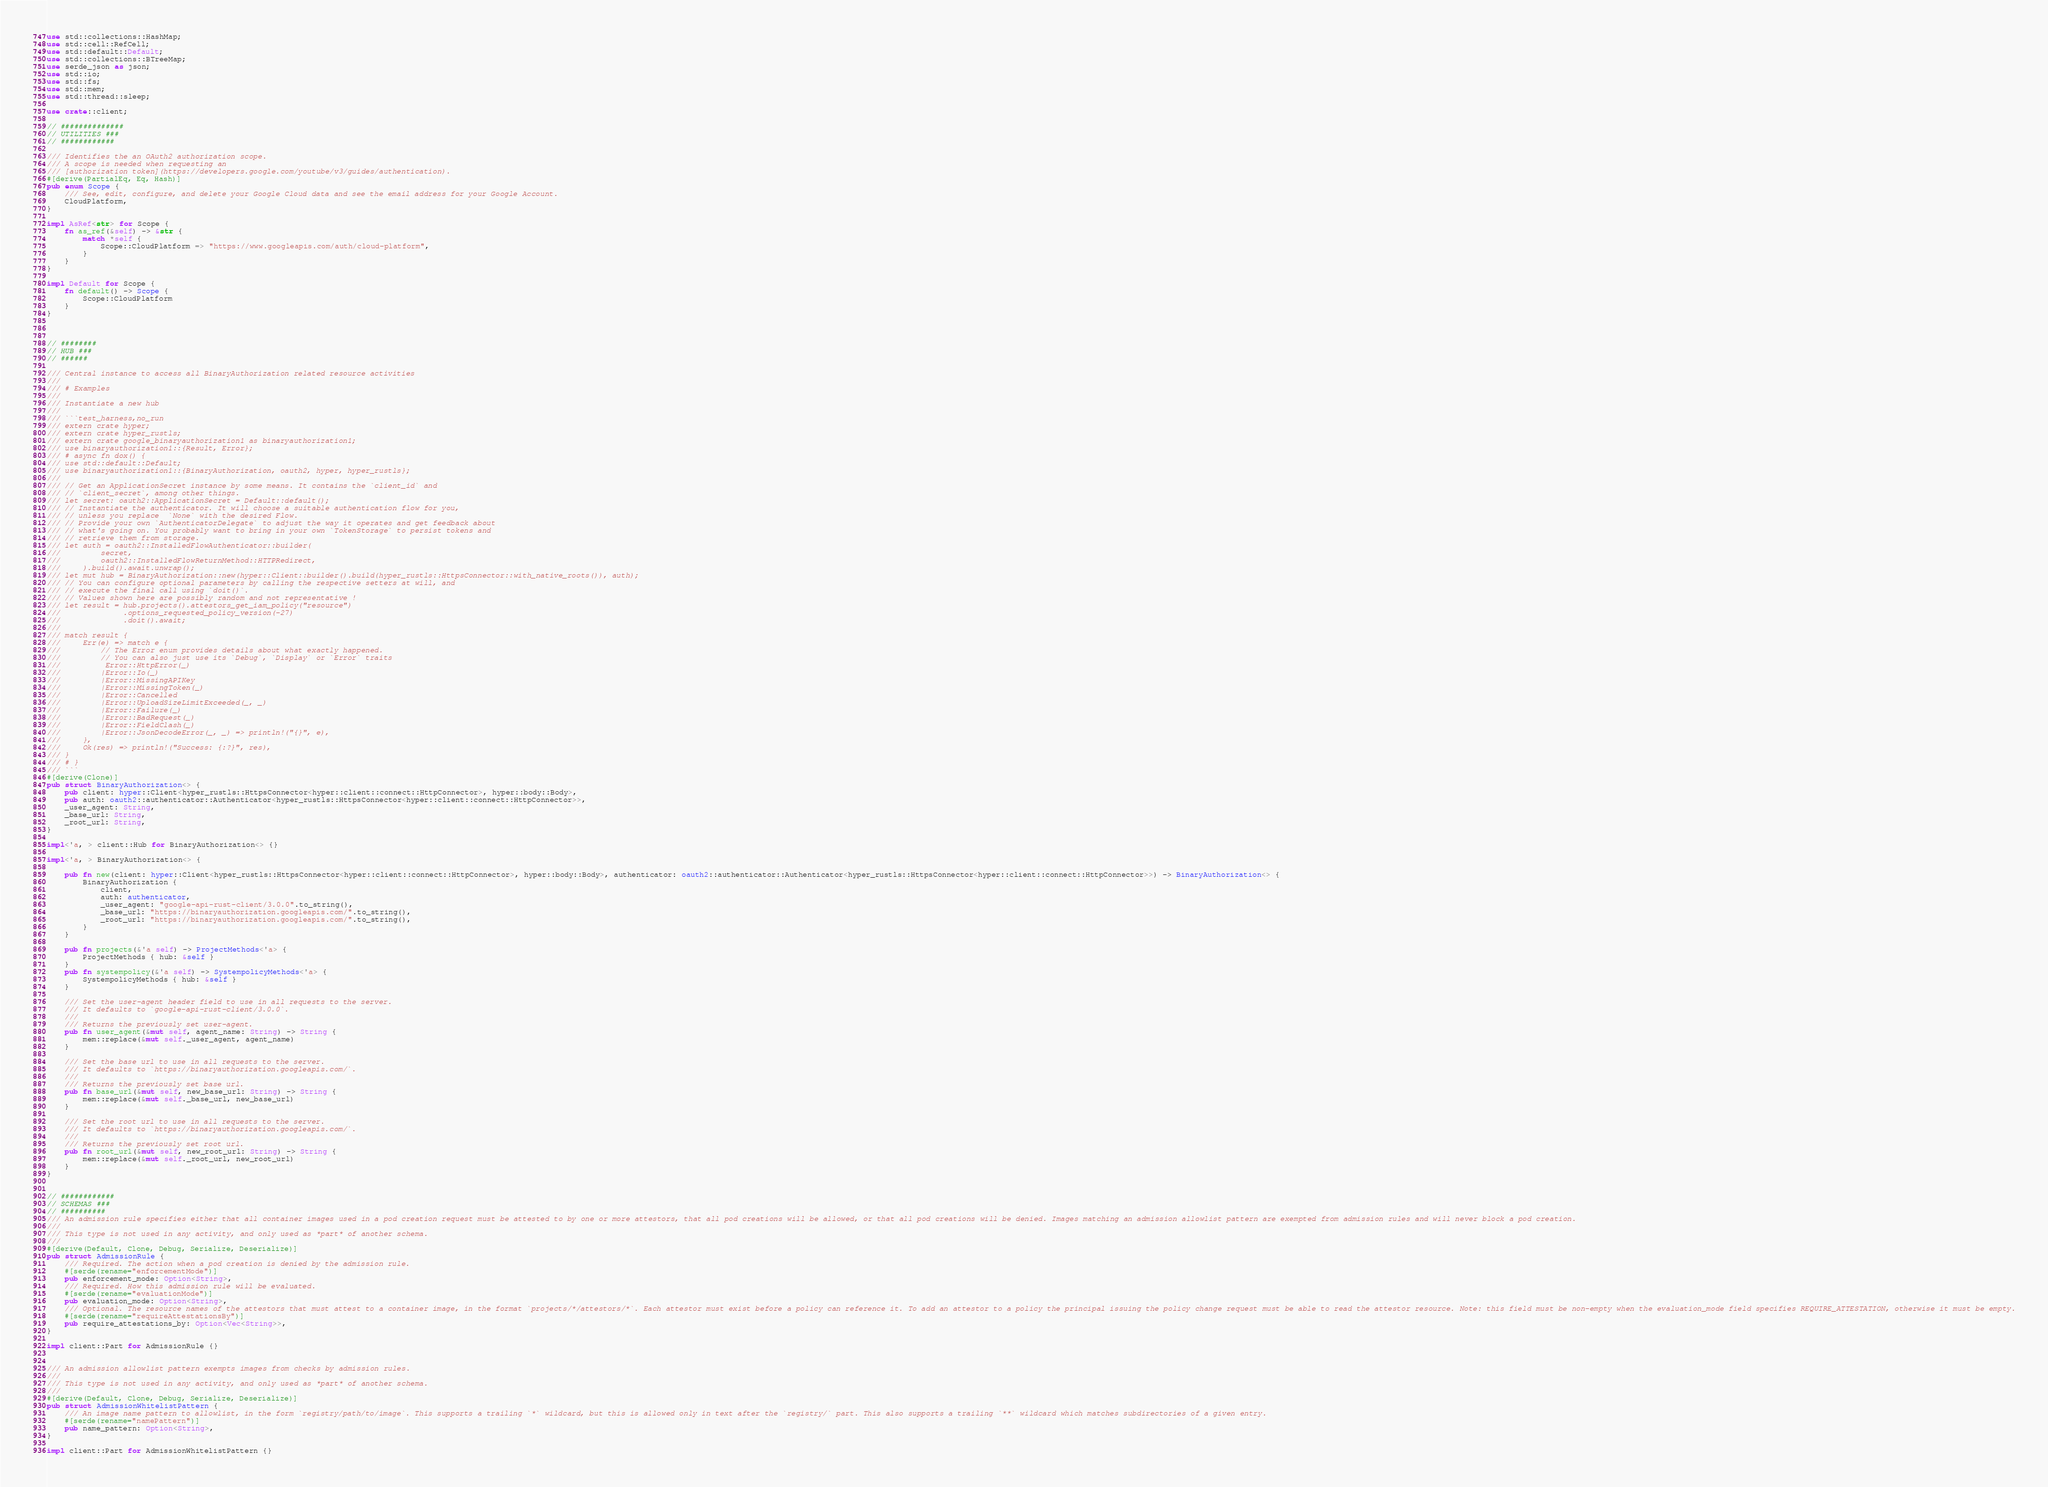<code> <loc_0><loc_0><loc_500><loc_500><_Rust_>use std::collections::HashMap;
use std::cell::RefCell;
use std::default::Default;
use std::collections::BTreeMap;
use serde_json as json;
use std::io;
use std::fs;
use std::mem;
use std::thread::sleep;

use crate::client;

// ##############
// UTILITIES ###
// ############

/// Identifies the an OAuth2 authorization scope.
/// A scope is needed when requesting an
/// [authorization token](https://developers.google.com/youtube/v3/guides/authentication).
#[derive(PartialEq, Eq, Hash)]
pub enum Scope {
    /// See, edit, configure, and delete your Google Cloud data and see the email address for your Google Account.
    CloudPlatform,
}

impl AsRef<str> for Scope {
    fn as_ref(&self) -> &str {
        match *self {
            Scope::CloudPlatform => "https://www.googleapis.com/auth/cloud-platform",
        }
    }
}

impl Default for Scope {
    fn default() -> Scope {
        Scope::CloudPlatform
    }
}



// ########
// HUB ###
// ######

/// Central instance to access all BinaryAuthorization related resource activities
///
/// # Examples
///
/// Instantiate a new hub
///
/// ```test_harness,no_run
/// extern crate hyper;
/// extern crate hyper_rustls;
/// extern crate google_binaryauthorization1 as binaryauthorization1;
/// use binaryauthorization1::{Result, Error};
/// # async fn dox() {
/// use std::default::Default;
/// use binaryauthorization1::{BinaryAuthorization, oauth2, hyper, hyper_rustls};
/// 
/// // Get an ApplicationSecret instance by some means. It contains the `client_id` and 
/// // `client_secret`, among other things.
/// let secret: oauth2::ApplicationSecret = Default::default();
/// // Instantiate the authenticator. It will choose a suitable authentication flow for you, 
/// // unless you replace  `None` with the desired Flow.
/// // Provide your own `AuthenticatorDelegate` to adjust the way it operates and get feedback about 
/// // what's going on. You probably want to bring in your own `TokenStorage` to persist tokens and
/// // retrieve them from storage.
/// let auth = oauth2::InstalledFlowAuthenticator::builder(
///         secret,
///         oauth2::InstalledFlowReturnMethod::HTTPRedirect,
///     ).build().await.unwrap();
/// let mut hub = BinaryAuthorization::new(hyper::Client::builder().build(hyper_rustls::HttpsConnector::with_native_roots()), auth);
/// // You can configure optional parameters by calling the respective setters at will, and
/// // execute the final call using `doit()`.
/// // Values shown here are possibly random and not representative !
/// let result = hub.projects().attestors_get_iam_policy("resource")
///              .options_requested_policy_version(-27)
///              .doit().await;
/// 
/// match result {
///     Err(e) => match e {
///         // The Error enum provides details about what exactly happened.
///         // You can also just use its `Debug`, `Display` or `Error` traits
///          Error::HttpError(_)
///         |Error::Io(_)
///         |Error::MissingAPIKey
///         |Error::MissingToken(_)
///         |Error::Cancelled
///         |Error::UploadSizeLimitExceeded(_, _)
///         |Error::Failure(_)
///         |Error::BadRequest(_)
///         |Error::FieldClash(_)
///         |Error::JsonDecodeError(_, _) => println!("{}", e),
///     },
///     Ok(res) => println!("Success: {:?}", res),
/// }
/// # }
/// ```
#[derive(Clone)]
pub struct BinaryAuthorization<> {
    pub client: hyper::Client<hyper_rustls::HttpsConnector<hyper::client::connect::HttpConnector>, hyper::body::Body>,
    pub auth: oauth2::authenticator::Authenticator<hyper_rustls::HttpsConnector<hyper::client::connect::HttpConnector>>,
    _user_agent: String,
    _base_url: String,
    _root_url: String,
}

impl<'a, > client::Hub for BinaryAuthorization<> {}

impl<'a, > BinaryAuthorization<> {

    pub fn new(client: hyper::Client<hyper_rustls::HttpsConnector<hyper::client::connect::HttpConnector>, hyper::body::Body>, authenticator: oauth2::authenticator::Authenticator<hyper_rustls::HttpsConnector<hyper::client::connect::HttpConnector>>) -> BinaryAuthorization<> {
        BinaryAuthorization {
            client,
            auth: authenticator,
            _user_agent: "google-api-rust-client/3.0.0".to_string(),
            _base_url: "https://binaryauthorization.googleapis.com/".to_string(),
            _root_url: "https://binaryauthorization.googleapis.com/".to_string(),
        }
    }

    pub fn projects(&'a self) -> ProjectMethods<'a> {
        ProjectMethods { hub: &self }
    }
    pub fn systempolicy(&'a self) -> SystempolicyMethods<'a> {
        SystempolicyMethods { hub: &self }
    }

    /// Set the user-agent header field to use in all requests to the server.
    /// It defaults to `google-api-rust-client/3.0.0`.
    ///
    /// Returns the previously set user-agent.
    pub fn user_agent(&mut self, agent_name: String) -> String {
        mem::replace(&mut self._user_agent, agent_name)
    }

    /// Set the base url to use in all requests to the server.
    /// It defaults to `https://binaryauthorization.googleapis.com/`.
    ///
    /// Returns the previously set base url.
    pub fn base_url(&mut self, new_base_url: String) -> String {
        mem::replace(&mut self._base_url, new_base_url)
    }

    /// Set the root url to use in all requests to the server.
    /// It defaults to `https://binaryauthorization.googleapis.com/`.
    ///
    /// Returns the previously set root url.
    pub fn root_url(&mut self, new_root_url: String) -> String {
        mem::replace(&mut self._root_url, new_root_url)
    }
}


// ############
// SCHEMAS ###
// ##########
/// An admission rule specifies either that all container images used in a pod creation request must be attested to by one or more attestors, that all pod creations will be allowed, or that all pod creations will be denied. Images matching an admission allowlist pattern are exempted from admission rules and will never block a pod creation.
/// 
/// This type is not used in any activity, and only used as *part* of another schema.
/// 
#[derive(Default, Clone, Debug, Serialize, Deserialize)]
pub struct AdmissionRule {
    /// Required. The action when a pod creation is denied by the admission rule.
    #[serde(rename="enforcementMode")]
    pub enforcement_mode: Option<String>,
    /// Required. How this admission rule will be evaluated.
    #[serde(rename="evaluationMode")]
    pub evaluation_mode: Option<String>,
    /// Optional. The resource names of the attestors that must attest to a container image, in the format `projects/*/attestors/*`. Each attestor must exist before a policy can reference it. To add an attestor to a policy the principal issuing the policy change request must be able to read the attestor resource. Note: this field must be non-empty when the evaluation_mode field specifies REQUIRE_ATTESTATION, otherwise it must be empty.
    #[serde(rename="requireAttestationsBy")]
    pub require_attestations_by: Option<Vec<String>>,
}

impl client::Part for AdmissionRule {}


/// An admission allowlist pattern exempts images from checks by admission rules.
/// 
/// This type is not used in any activity, and only used as *part* of another schema.
/// 
#[derive(Default, Clone, Debug, Serialize, Deserialize)]
pub struct AdmissionWhitelistPattern {
    /// An image name pattern to allowlist, in the form `registry/path/to/image`. This supports a trailing `*` wildcard, but this is allowed only in text after the `registry/` part. This also supports a trailing `**` wildcard which matches subdirectories of a given entry.
    #[serde(rename="namePattern")]
    pub name_pattern: Option<String>,
}

impl client::Part for AdmissionWhitelistPattern {}

</code> 